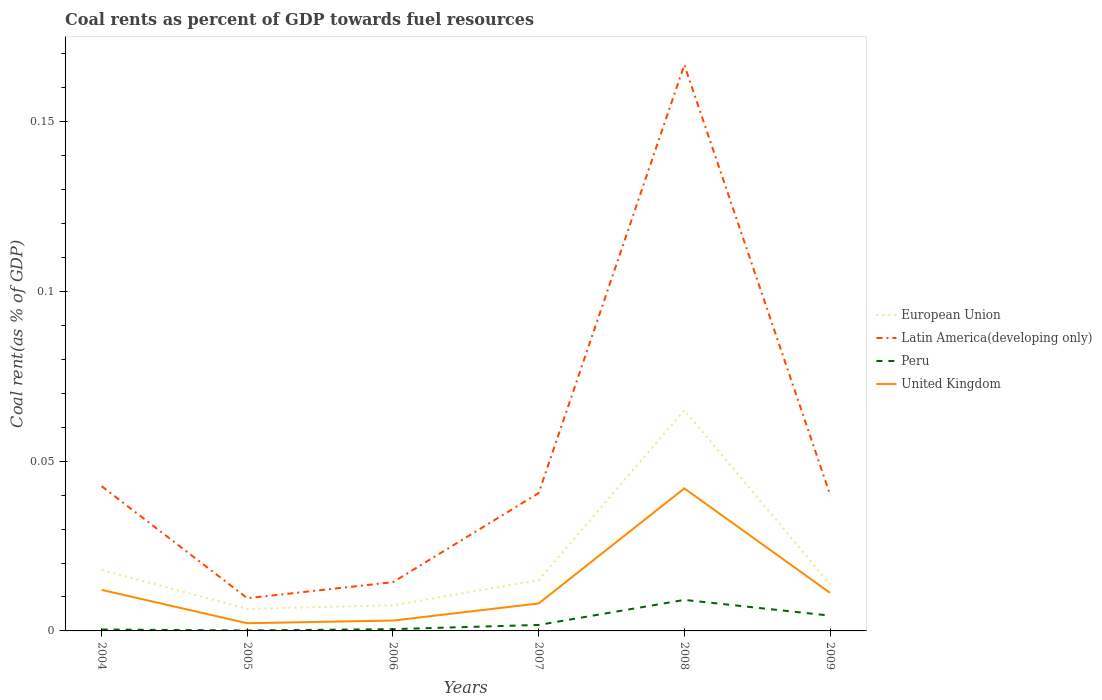Across all years, what is the maximum coal rent in United Kingdom?
Give a very brief answer. 0. What is the total coal rent in United Kingdom in the graph?
Give a very brief answer. -0.03. What is the difference between the highest and the second highest coal rent in European Union?
Your answer should be compact. 0.06. Is the coal rent in European Union strictly greater than the coal rent in Latin America(developing only) over the years?
Offer a terse response. Yes. Are the values on the major ticks of Y-axis written in scientific E-notation?
Give a very brief answer. No. Does the graph contain any zero values?
Offer a terse response. No. Does the graph contain grids?
Offer a very short reply. No. Where does the legend appear in the graph?
Offer a very short reply. Center right. How many legend labels are there?
Offer a terse response. 4. How are the legend labels stacked?
Your response must be concise. Vertical. What is the title of the graph?
Provide a short and direct response. Coal rents as percent of GDP towards fuel resources. What is the label or title of the X-axis?
Offer a very short reply. Years. What is the label or title of the Y-axis?
Offer a very short reply. Coal rent(as % of GDP). What is the Coal rent(as % of GDP) of European Union in 2004?
Ensure brevity in your answer.  0.02. What is the Coal rent(as % of GDP) of Latin America(developing only) in 2004?
Offer a terse response. 0.04. What is the Coal rent(as % of GDP) of Peru in 2004?
Ensure brevity in your answer.  0. What is the Coal rent(as % of GDP) in United Kingdom in 2004?
Make the answer very short. 0.01. What is the Coal rent(as % of GDP) of European Union in 2005?
Offer a very short reply. 0.01. What is the Coal rent(as % of GDP) in Latin America(developing only) in 2005?
Provide a succinct answer. 0.01. What is the Coal rent(as % of GDP) of Peru in 2005?
Offer a terse response. 0. What is the Coal rent(as % of GDP) in United Kingdom in 2005?
Provide a short and direct response. 0. What is the Coal rent(as % of GDP) of European Union in 2006?
Your response must be concise. 0.01. What is the Coal rent(as % of GDP) in Latin America(developing only) in 2006?
Ensure brevity in your answer.  0.01. What is the Coal rent(as % of GDP) in Peru in 2006?
Your answer should be compact. 0. What is the Coal rent(as % of GDP) in United Kingdom in 2006?
Ensure brevity in your answer.  0. What is the Coal rent(as % of GDP) of European Union in 2007?
Your response must be concise. 0.01. What is the Coal rent(as % of GDP) of Latin America(developing only) in 2007?
Ensure brevity in your answer.  0.04. What is the Coal rent(as % of GDP) of Peru in 2007?
Keep it short and to the point. 0. What is the Coal rent(as % of GDP) in United Kingdom in 2007?
Give a very brief answer. 0.01. What is the Coal rent(as % of GDP) in European Union in 2008?
Your answer should be compact. 0.07. What is the Coal rent(as % of GDP) of Latin America(developing only) in 2008?
Offer a terse response. 0.17. What is the Coal rent(as % of GDP) of Peru in 2008?
Offer a terse response. 0.01. What is the Coal rent(as % of GDP) of United Kingdom in 2008?
Offer a terse response. 0.04. What is the Coal rent(as % of GDP) of European Union in 2009?
Provide a succinct answer. 0.01. What is the Coal rent(as % of GDP) in Latin America(developing only) in 2009?
Your response must be concise. 0.04. What is the Coal rent(as % of GDP) of Peru in 2009?
Ensure brevity in your answer.  0. What is the Coal rent(as % of GDP) in United Kingdom in 2009?
Offer a terse response. 0.01. Across all years, what is the maximum Coal rent(as % of GDP) in European Union?
Make the answer very short. 0.07. Across all years, what is the maximum Coal rent(as % of GDP) in Latin America(developing only)?
Ensure brevity in your answer.  0.17. Across all years, what is the maximum Coal rent(as % of GDP) in Peru?
Offer a very short reply. 0.01. Across all years, what is the maximum Coal rent(as % of GDP) in United Kingdom?
Ensure brevity in your answer.  0.04. Across all years, what is the minimum Coal rent(as % of GDP) in European Union?
Offer a terse response. 0.01. Across all years, what is the minimum Coal rent(as % of GDP) in Latin America(developing only)?
Offer a terse response. 0.01. Across all years, what is the minimum Coal rent(as % of GDP) in Peru?
Offer a terse response. 0. Across all years, what is the minimum Coal rent(as % of GDP) of United Kingdom?
Ensure brevity in your answer.  0. What is the total Coal rent(as % of GDP) of European Union in the graph?
Make the answer very short. 0.13. What is the total Coal rent(as % of GDP) of Latin America(developing only) in the graph?
Give a very brief answer. 0.31. What is the total Coal rent(as % of GDP) of Peru in the graph?
Ensure brevity in your answer.  0.02. What is the total Coal rent(as % of GDP) of United Kingdom in the graph?
Your answer should be compact. 0.08. What is the difference between the Coal rent(as % of GDP) in European Union in 2004 and that in 2005?
Ensure brevity in your answer.  0.01. What is the difference between the Coal rent(as % of GDP) of Latin America(developing only) in 2004 and that in 2005?
Offer a very short reply. 0.03. What is the difference between the Coal rent(as % of GDP) of Peru in 2004 and that in 2005?
Ensure brevity in your answer.  0. What is the difference between the Coal rent(as % of GDP) in United Kingdom in 2004 and that in 2005?
Keep it short and to the point. 0.01. What is the difference between the Coal rent(as % of GDP) in European Union in 2004 and that in 2006?
Provide a succinct answer. 0.01. What is the difference between the Coal rent(as % of GDP) in Latin America(developing only) in 2004 and that in 2006?
Provide a succinct answer. 0.03. What is the difference between the Coal rent(as % of GDP) of Peru in 2004 and that in 2006?
Make the answer very short. -0. What is the difference between the Coal rent(as % of GDP) in United Kingdom in 2004 and that in 2006?
Keep it short and to the point. 0.01. What is the difference between the Coal rent(as % of GDP) of European Union in 2004 and that in 2007?
Offer a terse response. 0. What is the difference between the Coal rent(as % of GDP) in Latin America(developing only) in 2004 and that in 2007?
Keep it short and to the point. 0. What is the difference between the Coal rent(as % of GDP) of Peru in 2004 and that in 2007?
Provide a short and direct response. -0. What is the difference between the Coal rent(as % of GDP) of United Kingdom in 2004 and that in 2007?
Your answer should be very brief. 0. What is the difference between the Coal rent(as % of GDP) in European Union in 2004 and that in 2008?
Provide a succinct answer. -0.05. What is the difference between the Coal rent(as % of GDP) in Latin America(developing only) in 2004 and that in 2008?
Provide a succinct answer. -0.12. What is the difference between the Coal rent(as % of GDP) in Peru in 2004 and that in 2008?
Offer a very short reply. -0.01. What is the difference between the Coal rent(as % of GDP) in United Kingdom in 2004 and that in 2008?
Your answer should be very brief. -0.03. What is the difference between the Coal rent(as % of GDP) of European Union in 2004 and that in 2009?
Provide a short and direct response. 0. What is the difference between the Coal rent(as % of GDP) of Latin America(developing only) in 2004 and that in 2009?
Provide a succinct answer. 0. What is the difference between the Coal rent(as % of GDP) of Peru in 2004 and that in 2009?
Provide a succinct answer. -0. What is the difference between the Coal rent(as % of GDP) in United Kingdom in 2004 and that in 2009?
Your answer should be very brief. 0. What is the difference between the Coal rent(as % of GDP) in European Union in 2005 and that in 2006?
Offer a terse response. -0. What is the difference between the Coal rent(as % of GDP) in Latin America(developing only) in 2005 and that in 2006?
Keep it short and to the point. -0. What is the difference between the Coal rent(as % of GDP) of Peru in 2005 and that in 2006?
Give a very brief answer. -0. What is the difference between the Coal rent(as % of GDP) of United Kingdom in 2005 and that in 2006?
Give a very brief answer. -0. What is the difference between the Coal rent(as % of GDP) in European Union in 2005 and that in 2007?
Provide a succinct answer. -0.01. What is the difference between the Coal rent(as % of GDP) in Latin America(developing only) in 2005 and that in 2007?
Make the answer very short. -0.03. What is the difference between the Coal rent(as % of GDP) in Peru in 2005 and that in 2007?
Give a very brief answer. -0. What is the difference between the Coal rent(as % of GDP) in United Kingdom in 2005 and that in 2007?
Provide a short and direct response. -0.01. What is the difference between the Coal rent(as % of GDP) in European Union in 2005 and that in 2008?
Your response must be concise. -0.06. What is the difference between the Coal rent(as % of GDP) in Latin America(developing only) in 2005 and that in 2008?
Provide a succinct answer. -0.16. What is the difference between the Coal rent(as % of GDP) in Peru in 2005 and that in 2008?
Offer a very short reply. -0.01. What is the difference between the Coal rent(as % of GDP) in United Kingdom in 2005 and that in 2008?
Your response must be concise. -0.04. What is the difference between the Coal rent(as % of GDP) in European Union in 2005 and that in 2009?
Make the answer very short. -0.01. What is the difference between the Coal rent(as % of GDP) in Latin America(developing only) in 2005 and that in 2009?
Your response must be concise. -0.03. What is the difference between the Coal rent(as % of GDP) in Peru in 2005 and that in 2009?
Provide a succinct answer. -0. What is the difference between the Coal rent(as % of GDP) in United Kingdom in 2005 and that in 2009?
Give a very brief answer. -0.01. What is the difference between the Coal rent(as % of GDP) of European Union in 2006 and that in 2007?
Your answer should be very brief. -0.01. What is the difference between the Coal rent(as % of GDP) of Latin America(developing only) in 2006 and that in 2007?
Provide a short and direct response. -0.03. What is the difference between the Coal rent(as % of GDP) in Peru in 2006 and that in 2007?
Offer a terse response. -0. What is the difference between the Coal rent(as % of GDP) of United Kingdom in 2006 and that in 2007?
Your response must be concise. -0.01. What is the difference between the Coal rent(as % of GDP) of European Union in 2006 and that in 2008?
Ensure brevity in your answer.  -0.06. What is the difference between the Coal rent(as % of GDP) in Latin America(developing only) in 2006 and that in 2008?
Offer a terse response. -0.15. What is the difference between the Coal rent(as % of GDP) of Peru in 2006 and that in 2008?
Your answer should be compact. -0.01. What is the difference between the Coal rent(as % of GDP) in United Kingdom in 2006 and that in 2008?
Your answer should be compact. -0.04. What is the difference between the Coal rent(as % of GDP) of European Union in 2006 and that in 2009?
Your answer should be very brief. -0.01. What is the difference between the Coal rent(as % of GDP) in Latin America(developing only) in 2006 and that in 2009?
Offer a terse response. -0.03. What is the difference between the Coal rent(as % of GDP) in Peru in 2006 and that in 2009?
Provide a succinct answer. -0. What is the difference between the Coal rent(as % of GDP) in United Kingdom in 2006 and that in 2009?
Keep it short and to the point. -0.01. What is the difference between the Coal rent(as % of GDP) of European Union in 2007 and that in 2008?
Ensure brevity in your answer.  -0.05. What is the difference between the Coal rent(as % of GDP) in Latin America(developing only) in 2007 and that in 2008?
Keep it short and to the point. -0.13. What is the difference between the Coal rent(as % of GDP) in Peru in 2007 and that in 2008?
Offer a terse response. -0.01. What is the difference between the Coal rent(as % of GDP) of United Kingdom in 2007 and that in 2008?
Provide a short and direct response. -0.03. What is the difference between the Coal rent(as % of GDP) of European Union in 2007 and that in 2009?
Provide a succinct answer. 0. What is the difference between the Coal rent(as % of GDP) in Latin America(developing only) in 2007 and that in 2009?
Your answer should be compact. 0. What is the difference between the Coal rent(as % of GDP) in Peru in 2007 and that in 2009?
Your response must be concise. -0. What is the difference between the Coal rent(as % of GDP) of United Kingdom in 2007 and that in 2009?
Keep it short and to the point. -0. What is the difference between the Coal rent(as % of GDP) of European Union in 2008 and that in 2009?
Make the answer very short. 0.05. What is the difference between the Coal rent(as % of GDP) in Latin America(developing only) in 2008 and that in 2009?
Your response must be concise. 0.13. What is the difference between the Coal rent(as % of GDP) in Peru in 2008 and that in 2009?
Ensure brevity in your answer.  0. What is the difference between the Coal rent(as % of GDP) of United Kingdom in 2008 and that in 2009?
Offer a very short reply. 0.03. What is the difference between the Coal rent(as % of GDP) of European Union in 2004 and the Coal rent(as % of GDP) of Latin America(developing only) in 2005?
Your answer should be very brief. 0.01. What is the difference between the Coal rent(as % of GDP) in European Union in 2004 and the Coal rent(as % of GDP) in Peru in 2005?
Provide a succinct answer. 0.02. What is the difference between the Coal rent(as % of GDP) in European Union in 2004 and the Coal rent(as % of GDP) in United Kingdom in 2005?
Your answer should be very brief. 0.02. What is the difference between the Coal rent(as % of GDP) of Latin America(developing only) in 2004 and the Coal rent(as % of GDP) of Peru in 2005?
Offer a very short reply. 0.04. What is the difference between the Coal rent(as % of GDP) of Latin America(developing only) in 2004 and the Coal rent(as % of GDP) of United Kingdom in 2005?
Make the answer very short. 0.04. What is the difference between the Coal rent(as % of GDP) of Peru in 2004 and the Coal rent(as % of GDP) of United Kingdom in 2005?
Keep it short and to the point. -0. What is the difference between the Coal rent(as % of GDP) of European Union in 2004 and the Coal rent(as % of GDP) of Latin America(developing only) in 2006?
Offer a very short reply. 0. What is the difference between the Coal rent(as % of GDP) in European Union in 2004 and the Coal rent(as % of GDP) in Peru in 2006?
Your answer should be very brief. 0.02. What is the difference between the Coal rent(as % of GDP) in European Union in 2004 and the Coal rent(as % of GDP) in United Kingdom in 2006?
Make the answer very short. 0.01. What is the difference between the Coal rent(as % of GDP) in Latin America(developing only) in 2004 and the Coal rent(as % of GDP) in Peru in 2006?
Your answer should be very brief. 0.04. What is the difference between the Coal rent(as % of GDP) of Latin America(developing only) in 2004 and the Coal rent(as % of GDP) of United Kingdom in 2006?
Ensure brevity in your answer.  0.04. What is the difference between the Coal rent(as % of GDP) in Peru in 2004 and the Coal rent(as % of GDP) in United Kingdom in 2006?
Provide a short and direct response. -0. What is the difference between the Coal rent(as % of GDP) in European Union in 2004 and the Coal rent(as % of GDP) in Latin America(developing only) in 2007?
Offer a very short reply. -0.02. What is the difference between the Coal rent(as % of GDP) in European Union in 2004 and the Coal rent(as % of GDP) in Peru in 2007?
Your response must be concise. 0.02. What is the difference between the Coal rent(as % of GDP) of European Union in 2004 and the Coal rent(as % of GDP) of United Kingdom in 2007?
Offer a very short reply. 0.01. What is the difference between the Coal rent(as % of GDP) in Latin America(developing only) in 2004 and the Coal rent(as % of GDP) in Peru in 2007?
Your answer should be very brief. 0.04. What is the difference between the Coal rent(as % of GDP) in Latin America(developing only) in 2004 and the Coal rent(as % of GDP) in United Kingdom in 2007?
Offer a very short reply. 0.03. What is the difference between the Coal rent(as % of GDP) of Peru in 2004 and the Coal rent(as % of GDP) of United Kingdom in 2007?
Your answer should be very brief. -0.01. What is the difference between the Coal rent(as % of GDP) in European Union in 2004 and the Coal rent(as % of GDP) in Latin America(developing only) in 2008?
Keep it short and to the point. -0.15. What is the difference between the Coal rent(as % of GDP) in European Union in 2004 and the Coal rent(as % of GDP) in Peru in 2008?
Provide a short and direct response. 0.01. What is the difference between the Coal rent(as % of GDP) in European Union in 2004 and the Coal rent(as % of GDP) in United Kingdom in 2008?
Offer a terse response. -0.02. What is the difference between the Coal rent(as % of GDP) in Latin America(developing only) in 2004 and the Coal rent(as % of GDP) in Peru in 2008?
Provide a short and direct response. 0.03. What is the difference between the Coal rent(as % of GDP) in Latin America(developing only) in 2004 and the Coal rent(as % of GDP) in United Kingdom in 2008?
Provide a short and direct response. 0. What is the difference between the Coal rent(as % of GDP) of Peru in 2004 and the Coal rent(as % of GDP) of United Kingdom in 2008?
Provide a short and direct response. -0.04. What is the difference between the Coal rent(as % of GDP) of European Union in 2004 and the Coal rent(as % of GDP) of Latin America(developing only) in 2009?
Provide a succinct answer. -0.02. What is the difference between the Coal rent(as % of GDP) of European Union in 2004 and the Coal rent(as % of GDP) of Peru in 2009?
Keep it short and to the point. 0.01. What is the difference between the Coal rent(as % of GDP) in European Union in 2004 and the Coal rent(as % of GDP) in United Kingdom in 2009?
Give a very brief answer. 0.01. What is the difference between the Coal rent(as % of GDP) of Latin America(developing only) in 2004 and the Coal rent(as % of GDP) of Peru in 2009?
Ensure brevity in your answer.  0.04. What is the difference between the Coal rent(as % of GDP) of Latin America(developing only) in 2004 and the Coal rent(as % of GDP) of United Kingdom in 2009?
Ensure brevity in your answer.  0.03. What is the difference between the Coal rent(as % of GDP) of Peru in 2004 and the Coal rent(as % of GDP) of United Kingdom in 2009?
Give a very brief answer. -0.01. What is the difference between the Coal rent(as % of GDP) of European Union in 2005 and the Coal rent(as % of GDP) of Latin America(developing only) in 2006?
Make the answer very short. -0.01. What is the difference between the Coal rent(as % of GDP) of European Union in 2005 and the Coal rent(as % of GDP) of Peru in 2006?
Ensure brevity in your answer.  0.01. What is the difference between the Coal rent(as % of GDP) of European Union in 2005 and the Coal rent(as % of GDP) of United Kingdom in 2006?
Offer a very short reply. 0. What is the difference between the Coal rent(as % of GDP) of Latin America(developing only) in 2005 and the Coal rent(as % of GDP) of Peru in 2006?
Give a very brief answer. 0.01. What is the difference between the Coal rent(as % of GDP) of Latin America(developing only) in 2005 and the Coal rent(as % of GDP) of United Kingdom in 2006?
Your answer should be compact. 0.01. What is the difference between the Coal rent(as % of GDP) of Peru in 2005 and the Coal rent(as % of GDP) of United Kingdom in 2006?
Keep it short and to the point. -0. What is the difference between the Coal rent(as % of GDP) in European Union in 2005 and the Coal rent(as % of GDP) in Latin America(developing only) in 2007?
Offer a terse response. -0.03. What is the difference between the Coal rent(as % of GDP) in European Union in 2005 and the Coal rent(as % of GDP) in Peru in 2007?
Your response must be concise. 0. What is the difference between the Coal rent(as % of GDP) in European Union in 2005 and the Coal rent(as % of GDP) in United Kingdom in 2007?
Your response must be concise. -0. What is the difference between the Coal rent(as % of GDP) of Latin America(developing only) in 2005 and the Coal rent(as % of GDP) of Peru in 2007?
Provide a succinct answer. 0.01. What is the difference between the Coal rent(as % of GDP) in Latin America(developing only) in 2005 and the Coal rent(as % of GDP) in United Kingdom in 2007?
Offer a very short reply. 0. What is the difference between the Coal rent(as % of GDP) of Peru in 2005 and the Coal rent(as % of GDP) of United Kingdom in 2007?
Provide a succinct answer. -0.01. What is the difference between the Coal rent(as % of GDP) of European Union in 2005 and the Coal rent(as % of GDP) of Latin America(developing only) in 2008?
Your answer should be compact. -0.16. What is the difference between the Coal rent(as % of GDP) in European Union in 2005 and the Coal rent(as % of GDP) in Peru in 2008?
Offer a very short reply. -0. What is the difference between the Coal rent(as % of GDP) of European Union in 2005 and the Coal rent(as % of GDP) of United Kingdom in 2008?
Your answer should be compact. -0.04. What is the difference between the Coal rent(as % of GDP) in Latin America(developing only) in 2005 and the Coal rent(as % of GDP) in United Kingdom in 2008?
Offer a terse response. -0.03. What is the difference between the Coal rent(as % of GDP) of Peru in 2005 and the Coal rent(as % of GDP) of United Kingdom in 2008?
Keep it short and to the point. -0.04. What is the difference between the Coal rent(as % of GDP) in European Union in 2005 and the Coal rent(as % of GDP) in Latin America(developing only) in 2009?
Offer a very short reply. -0.03. What is the difference between the Coal rent(as % of GDP) of European Union in 2005 and the Coal rent(as % of GDP) of Peru in 2009?
Give a very brief answer. 0. What is the difference between the Coal rent(as % of GDP) of European Union in 2005 and the Coal rent(as % of GDP) of United Kingdom in 2009?
Ensure brevity in your answer.  -0. What is the difference between the Coal rent(as % of GDP) of Latin America(developing only) in 2005 and the Coal rent(as % of GDP) of Peru in 2009?
Keep it short and to the point. 0.01. What is the difference between the Coal rent(as % of GDP) in Latin America(developing only) in 2005 and the Coal rent(as % of GDP) in United Kingdom in 2009?
Your answer should be compact. -0. What is the difference between the Coal rent(as % of GDP) in Peru in 2005 and the Coal rent(as % of GDP) in United Kingdom in 2009?
Keep it short and to the point. -0.01. What is the difference between the Coal rent(as % of GDP) in European Union in 2006 and the Coal rent(as % of GDP) in Latin America(developing only) in 2007?
Make the answer very short. -0.03. What is the difference between the Coal rent(as % of GDP) in European Union in 2006 and the Coal rent(as % of GDP) in Peru in 2007?
Make the answer very short. 0.01. What is the difference between the Coal rent(as % of GDP) in European Union in 2006 and the Coal rent(as % of GDP) in United Kingdom in 2007?
Your answer should be compact. -0. What is the difference between the Coal rent(as % of GDP) in Latin America(developing only) in 2006 and the Coal rent(as % of GDP) in Peru in 2007?
Offer a terse response. 0.01. What is the difference between the Coal rent(as % of GDP) of Latin America(developing only) in 2006 and the Coal rent(as % of GDP) of United Kingdom in 2007?
Keep it short and to the point. 0.01. What is the difference between the Coal rent(as % of GDP) of Peru in 2006 and the Coal rent(as % of GDP) of United Kingdom in 2007?
Provide a short and direct response. -0.01. What is the difference between the Coal rent(as % of GDP) of European Union in 2006 and the Coal rent(as % of GDP) of Latin America(developing only) in 2008?
Make the answer very short. -0.16. What is the difference between the Coal rent(as % of GDP) in European Union in 2006 and the Coal rent(as % of GDP) in Peru in 2008?
Keep it short and to the point. -0. What is the difference between the Coal rent(as % of GDP) in European Union in 2006 and the Coal rent(as % of GDP) in United Kingdom in 2008?
Ensure brevity in your answer.  -0.03. What is the difference between the Coal rent(as % of GDP) in Latin America(developing only) in 2006 and the Coal rent(as % of GDP) in Peru in 2008?
Ensure brevity in your answer.  0.01. What is the difference between the Coal rent(as % of GDP) in Latin America(developing only) in 2006 and the Coal rent(as % of GDP) in United Kingdom in 2008?
Keep it short and to the point. -0.03. What is the difference between the Coal rent(as % of GDP) of Peru in 2006 and the Coal rent(as % of GDP) of United Kingdom in 2008?
Offer a very short reply. -0.04. What is the difference between the Coal rent(as % of GDP) of European Union in 2006 and the Coal rent(as % of GDP) of Latin America(developing only) in 2009?
Provide a short and direct response. -0.03. What is the difference between the Coal rent(as % of GDP) of European Union in 2006 and the Coal rent(as % of GDP) of Peru in 2009?
Your answer should be compact. 0. What is the difference between the Coal rent(as % of GDP) of European Union in 2006 and the Coal rent(as % of GDP) of United Kingdom in 2009?
Your response must be concise. -0. What is the difference between the Coal rent(as % of GDP) in Latin America(developing only) in 2006 and the Coal rent(as % of GDP) in Peru in 2009?
Offer a terse response. 0.01. What is the difference between the Coal rent(as % of GDP) of Latin America(developing only) in 2006 and the Coal rent(as % of GDP) of United Kingdom in 2009?
Offer a terse response. 0. What is the difference between the Coal rent(as % of GDP) in Peru in 2006 and the Coal rent(as % of GDP) in United Kingdom in 2009?
Offer a very short reply. -0.01. What is the difference between the Coal rent(as % of GDP) of European Union in 2007 and the Coal rent(as % of GDP) of Latin America(developing only) in 2008?
Offer a terse response. -0.15. What is the difference between the Coal rent(as % of GDP) in European Union in 2007 and the Coal rent(as % of GDP) in Peru in 2008?
Your answer should be compact. 0.01. What is the difference between the Coal rent(as % of GDP) of European Union in 2007 and the Coal rent(as % of GDP) of United Kingdom in 2008?
Offer a very short reply. -0.03. What is the difference between the Coal rent(as % of GDP) in Latin America(developing only) in 2007 and the Coal rent(as % of GDP) in Peru in 2008?
Ensure brevity in your answer.  0.03. What is the difference between the Coal rent(as % of GDP) of Latin America(developing only) in 2007 and the Coal rent(as % of GDP) of United Kingdom in 2008?
Provide a succinct answer. -0. What is the difference between the Coal rent(as % of GDP) of Peru in 2007 and the Coal rent(as % of GDP) of United Kingdom in 2008?
Give a very brief answer. -0.04. What is the difference between the Coal rent(as % of GDP) in European Union in 2007 and the Coal rent(as % of GDP) in Latin America(developing only) in 2009?
Your answer should be compact. -0.03. What is the difference between the Coal rent(as % of GDP) of European Union in 2007 and the Coal rent(as % of GDP) of Peru in 2009?
Give a very brief answer. 0.01. What is the difference between the Coal rent(as % of GDP) of European Union in 2007 and the Coal rent(as % of GDP) of United Kingdom in 2009?
Give a very brief answer. 0. What is the difference between the Coal rent(as % of GDP) in Latin America(developing only) in 2007 and the Coal rent(as % of GDP) in Peru in 2009?
Your answer should be compact. 0.04. What is the difference between the Coal rent(as % of GDP) in Latin America(developing only) in 2007 and the Coal rent(as % of GDP) in United Kingdom in 2009?
Ensure brevity in your answer.  0.03. What is the difference between the Coal rent(as % of GDP) in Peru in 2007 and the Coal rent(as % of GDP) in United Kingdom in 2009?
Offer a very short reply. -0.01. What is the difference between the Coal rent(as % of GDP) of European Union in 2008 and the Coal rent(as % of GDP) of Latin America(developing only) in 2009?
Provide a succinct answer. 0.02. What is the difference between the Coal rent(as % of GDP) of European Union in 2008 and the Coal rent(as % of GDP) of Peru in 2009?
Offer a very short reply. 0.06. What is the difference between the Coal rent(as % of GDP) of European Union in 2008 and the Coal rent(as % of GDP) of United Kingdom in 2009?
Offer a terse response. 0.05. What is the difference between the Coal rent(as % of GDP) of Latin America(developing only) in 2008 and the Coal rent(as % of GDP) of Peru in 2009?
Provide a succinct answer. 0.16. What is the difference between the Coal rent(as % of GDP) in Latin America(developing only) in 2008 and the Coal rent(as % of GDP) in United Kingdom in 2009?
Your answer should be very brief. 0.16. What is the difference between the Coal rent(as % of GDP) in Peru in 2008 and the Coal rent(as % of GDP) in United Kingdom in 2009?
Your response must be concise. -0. What is the average Coal rent(as % of GDP) in European Union per year?
Give a very brief answer. 0.02. What is the average Coal rent(as % of GDP) in Latin America(developing only) per year?
Your answer should be very brief. 0.05. What is the average Coal rent(as % of GDP) in Peru per year?
Make the answer very short. 0. What is the average Coal rent(as % of GDP) in United Kingdom per year?
Keep it short and to the point. 0.01. In the year 2004, what is the difference between the Coal rent(as % of GDP) of European Union and Coal rent(as % of GDP) of Latin America(developing only)?
Offer a very short reply. -0.02. In the year 2004, what is the difference between the Coal rent(as % of GDP) of European Union and Coal rent(as % of GDP) of Peru?
Your answer should be compact. 0.02. In the year 2004, what is the difference between the Coal rent(as % of GDP) in European Union and Coal rent(as % of GDP) in United Kingdom?
Your answer should be very brief. 0.01. In the year 2004, what is the difference between the Coal rent(as % of GDP) of Latin America(developing only) and Coal rent(as % of GDP) of Peru?
Provide a succinct answer. 0.04. In the year 2004, what is the difference between the Coal rent(as % of GDP) of Latin America(developing only) and Coal rent(as % of GDP) of United Kingdom?
Provide a short and direct response. 0.03. In the year 2004, what is the difference between the Coal rent(as % of GDP) of Peru and Coal rent(as % of GDP) of United Kingdom?
Keep it short and to the point. -0.01. In the year 2005, what is the difference between the Coal rent(as % of GDP) of European Union and Coal rent(as % of GDP) of Latin America(developing only)?
Make the answer very short. -0. In the year 2005, what is the difference between the Coal rent(as % of GDP) in European Union and Coal rent(as % of GDP) in Peru?
Offer a very short reply. 0.01. In the year 2005, what is the difference between the Coal rent(as % of GDP) in European Union and Coal rent(as % of GDP) in United Kingdom?
Your answer should be very brief. 0. In the year 2005, what is the difference between the Coal rent(as % of GDP) in Latin America(developing only) and Coal rent(as % of GDP) in Peru?
Offer a terse response. 0.01. In the year 2005, what is the difference between the Coal rent(as % of GDP) in Latin America(developing only) and Coal rent(as % of GDP) in United Kingdom?
Provide a short and direct response. 0.01. In the year 2005, what is the difference between the Coal rent(as % of GDP) in Peru and Coal rent(as % of GDP) in United Kingdom?
Offer a very short reply. -0. In the year 2006, what is the difference between the Coal rent(as % of GDP) of European Union and Coal rent(as % of GDP) of Latin America(developing only)?
Keep it short and to the point. -0.01. In the year 2006, what is the difference between the Coal rent(as % of GDP) in European Union and Coal rent(as % of GDP) in Peru?
Your response must be concise. 0.01. In the year 2006, what is the difference between the Coal rent(as % of GDP) in European Union and Coal rent(as % of GDP) in United Kingdom?
Give a very brief answer. 0. In the year 2006, what is the difference between the Coal rent(as % of GDP) of Latin America(developing only) and Coal rent(as % of GDP) of Peru?
Provide a succinct answer. 0.01. In the year 2006, what is the difference between the Coal rent(as % of GDP) in Latin America(developing only) and Coal rent(as % of GDP) in United Kingdom?
Ensure brevity in your answer.  0.01. In the year 2006, what is the difference between the Coal rent(as % of GDP) of Peru and Coal rent(as % of GDP) of United Kingdom?
Give a very brief answer. -0. In the year 2007, what is the difference between the Coal rent(as % of GDP) in European Union and Coal rent(as % of GDP) in Latin America(developing only)?
Provide a short and direct response. -0.03. In the year 2007, what is the difference between the Coal rent(as % of GDP) in European Union and Coal rent(as % of GDP) in Peru?
Provide a short and direct response. 0.01. In the year 2007, what is the difference between the Coal rent(as % of GDP) of European Union and Coal rent(as % of GDP) of United Kingdom?
Make the answer very short. 0.01. In the year 2007, what is the difference between the Coal rent(as % of GDP) of Latin America(developing only) and Coal rent(as % of GDP) of Peru?
Ensure brevity in your answer.  0.04. In the year 2007, what is the difference between the Coal rent(as % of GDP) in Latin America(developing only) and Coal rent(as % of GDP) in United Kingdom?
Make the answer very short. 0.03. In the year 2007, what is the difference between the Coal rent(as % of GDP) of Peru and Coal rent(as % of GDP) of United Kingdom?
Your response must be concise. -0.01. In the year 2008, what is the difference between the Coal rent(as % of GDP) of European Union and Coal rent(as % of GDP) of Latin America(developing only)?
Your answer should be very brief. -0.1. In the year 2008, what is the difference between the Coal rent(as % of GDP) in European Union and Coal rent(as % of GDP) in Peru?
Offer a terse response. 0.06. In the year 2008, what is the difference between the Coal rent(as % of GDP) of European Union and Coal rent(as % of GDP) of United Kingdom?
Offer a very short reply. 0.02. In the year 2008, what is the difference between the Coal rent(as % of GDP) in Latin America(developing only) and Coal rent(as % of GDP) in Peru?
Give a very brief answer. 0.16. In the year 2008, what is the difference between the Coal rent(as % of GDP) of Latin America(developing only) and Coal rent(as % of GDP) of United Kingdom?
Your answer should be compact. 0.12. In the year 2008, what is the difference between the Coal rent(as % of GDP) of Peru and Coal rent(as % of GDP) of United Kingdom?
Keep it short and to the point. -0.03. In the year 2009, what is the difference between the Coal rent(as % of GDP) of European Union and Coal rent(as % of GDP) of Latin America(developing only)?
Ensure brevity in your answer.  -0.03. In the year 2009, what is the difference between the Coal rent(as % of GDP) in European Union and Coal rent(as % of GDP) in Peru?
Provide a succinct answer. 0.01. In the year 2009, what is the difference between the Coal rent(as % of GDP) of European Union and Coal rent(as % of GDP) of United Kingdom?
Make the answer very short. 0. In the year 2009, what is the difference between the Coal rent(as % of GDP) of Latin America(developing only) and Coal rent(as % of GDP) of Peru?
Your answer should be very brief. 0.04. In the year 2009, what is the difference between the Coal rent(as % of GDP) of Latin America(developing only) and Coal rent(as % of GDP) of United Kingdom?
Give a very brief answer. 0.03. In the year 2009, what is the difference between the Coal rent(as % of GDP) of Peru and Coal rent(as % of GDP) of United Kingdom?
Provide a succinct answer. -0.01. What is the ratio of the Coal rent(as % of GDP) in European Union in 2004 to that in 2005?
Offer a terse response. 2.77. What is the ratio of the Coal rent(as % of GDP) of Latin America(developing only) in 2004 to that in 2005?
Give a very brief answer. 4.42. What is the ratio of the Coal rent(as % of GDP) in Peru in 2004 to that in 2005?
Make the answer very short. 3.1. What is the ratio of the Coal rent(as % of GDP) in United Kingdom in 2004 to that in 2005?
Offer a very short reply. 5.34. What is the ratio of the Coal rent(as % of GDP) in European Union in 2004 to that in 2006?
Provide a succinct answer. 2.38. What is the ratio of the Coal rent(as % of GDP) of Latin America(developing only) in 2004 to that in 2006?
Offer a terse response. 2.97. What is the ratio of the Coal rent(as % of GDP) of Peru in 2004 to that in 2006?
Give a very brief answer. 0.79. What is the ratio of the Coal rent(as % of GDP) in United Kingdom in 2004 to that in 2006?
Keep it short and to the point. 3.96. What is the ratio of the Coal rent(as % of GDP) in European Union in 2004 to that in 2007?
Ensure brevity in your answer.  1.2. What is the ratio of the Coal rent(as % of GDP) of Latin America(developing only) in 2004 to that in 2007?
Your answer should be very brief. 1.05. What is the ratio of the Coal rent(as % of GDP) of Peru in 2004 to that in 2007?
Provide a short and direct response. 0.24. What is the ratio of the Coal rent(as % of GDP) of United Kingdom in 2004 to that in 2007?
Your answer should be compact. 1.49. What is the ratio of the Coal rent(as % of GDP) of European Union in 2004 to that in 2008?
Your answer should be compact. 0.28. What is the ratio of the Coal rent(as % of GDP) in Latin America(developing only) in 2004 to that in 2008?
Provide a short and direct response. 0.26. What is the ratio of the Coal rent(as % of GDP) in Peru in 2004 to that in 2008?
Ensure brevity in your answer.  0.05. What is the ratio of the Coal rent(as % of GDP) in United Kingdom in 2004 to that in 2008?
Keep it short and to the point. 0.29. What is the ratio of the Coal rent(as % of GDP) in European Union in 2004 to that in 2009?
Offer a very short reply. 1.31. What is the ratio of the Coal rent(as % of GDP) of Latin America(developing only) in 2004 to that in 2009?
Provide a short and direct response. 1.06. What is the ratio of the Coal rent(as % of GDP) in Peru in 2004 to that in 2009?
Keep it short and to the point. 0.09. What is the ratio of the Coal rent(as % of GDP) of United Kingdom in 2004 to that in 2009?
Ensure brevity in your answer.  1.08. What is the ratio of the Coal rent(as % of GDP) in European Union in 2005 to that in 2006?
Provide a short and direct response. 0.86. What is the ratio of the Coal rent(as % of GDP) in Latin America(developing only) in 2005 to that in 2006?
Give a very brief answer. 0.67. What is the ratio of the Coal rent(as % of GDP) of Peru in 2005 to that in 2006?
Ensure brevity in your answer.  0.26. What is the ratio of the Coal rent(as % of GDP) of United Kingdom in 2005 to that in 2006?
Give a very brief answer. 0.74. What is the ratio of the Coal rent(as % of GDP) in European Union in 2005 to that in 2007?
Make the answer very short. 0.43. What is the ratio of the Coal rent(as % of GDP) of Latin America(developing only) in 2005 to that in 2007?
Provide a short and direct response. 0.24. What is the ratio of the Coal rent(as % of GDP) of Peru in 2005 to that in 2007?
Provide a short and direct response. 0.08. What is the ratio of the Coal rent(as % of GDP) in United Kingdom in 2005 to that in 2007?
Make the answer very short. 0.28. What is the ratio of the Coal rent(as % of GDP) in European Union in 2005 to that in 2008?
Ensure brevity in your answer.  0.1. What is the ratio of the Coal rent(as % of GDP) in Latin America(developing only) in 2005 to that in 2008?
Make the answer very short. 0.06. What is the ratio of the Coal rent(as % of GDP) in Peru in 2005 to that in 2008?
Keep it short and to the point. 0.01. What is the ratio of the Coal rent(as % of GDP) of United Kingdom in 2005 to that in 2008?
Provide a succinct answer. 0.05. What is the ratio of the Coal rent(as % of GDP) of European Union in 2005 to that in 2009?
Your answer should be very brief. 0.47. What is the ratio of the Coal rent(as % of GDP) of Latin America(developing only) in 2005 to that in 2009?
Give a very brief answer. 0.24. What is the ratio of the Coal rent(as % of GDP) of Peru in 2005 to that in 2009?
Make the answer very short. 0.03. What is the ratio of the Coal rent(as % of GDP) in United Kingdom in 2005 to that in 2009?
Your answer should be very brief. 0.2. What is the ratio of the Coal rent(as % of GDP) in European Union in 2006 to that in 2007?
Give a very brief answer. 0.51. What is the ratio of the Coal rent(as % of GDP) of Latin America(developing only) in 2006 to that in 2007?
Keep it short and to the point. 0.35. What is the ratio of the Coal rent(as % of GDP) in Peru in 2006 to that in 2007?
Keep it short and to the point. 0.3. What is the ratio of the Coal rent(as % of GDP) of United Kingdom in 2006 to that in 2007?
Offer a very short reply. 0.38. What is the ratio of the Coal rent(as % of GDP) of European Union in 2006 to that in 2008?
Make the answer very short. 0.12. What is the ratio of the Coal rent(as % of GDP) in Latin America(developing only) in 2006 to that in 2008?
Your response must be concise. 0.09. What is the ratio of the Coal rent(as % of GDP) of Peru in 2006 to that in 2008?
Your response must be concise. 0.06. What is the ratio of the Coal rent(as % of GDP) of United Kingdom in 2006 to that in 2008?
Keep it short and to the point. 0.07. What is the ratio of the Coal rent(as % of GDP) of European Union in 2006 to that in 2009?
Your response must be concise. 0.55. What is the ratio of the Coal rent(as % of GDP) in Latin America(developing only) in 2006 to that in 2009?
Offer a very short reply. 0.36. What is the ratio of the Coal rent(as % of GDP) of Peru in 2006 to that in 2009?
Give a very brief answer. 0.12. What is the ratio of the Coal rent(as % of GDP) of United Kingdom in 2006 to that in 2009?
Ensure brevity in your answer.  0.27. What is the ratio of the Coal rent(as % of GDP) in European Union in 2007 to that in 2008?
Make the answer very short. 0.23. What is the ratio of the Coal rent(as % of GDP) in Latin America(developing only) in 2007 to that in 2008?
Provide a succinct answer. 0.24. What is the ratio of the Coal rent(as % of GDP) of Peru in 2007 to that in 2008?
Your answer should be compact. 0.19. What is the ratio of the Coal rent(as % of GDP) of United Kingdom in 2007 to that in 2008?
Offer a terse response. 0.19. What is the ratio of the Coal rent(as % of GDP) in European Union in 2007 to that in 2009?
Provide a succinct answer. 1.09. What is the ratio of the Coal rent(as % of GDP) of Peru in 2007 to that in 2009?
Offer a terse response. 0.39. What is the ratio of the Coal rent(as % of GDP) of United Kingdom in 2007 to that in 2009?
Give a very brief answer. 0.72. What is the ratio of the Coal rent(as % of GDP) of European Union in 2008 to that in 2009?
Offer a very short reply. 4.73. What is the ratio of the Coal rent(as % of GDP) in Latin America(developing only) in 2008 to that in 2009?
Your answer should be very brief. 4.15. What is the ratio of the Coal rent(as % of GDP) in Peru in 2008 to that in 2009?
Ensure brevity in your answer.  2.03. What is the ratio of the Coal rent(as % of GDP) of United Kingdom in 2008 to that in 2009?
Offer a terse response. 3.74. What is the difference between the highest and the second highest Coal rent(as % of GDP) of European Union?
Provide a succinct answer. 0.05. What is the difference between the highest and the second highest Coal rent(as % of GDP) of Latin America(developing only)?
Make the answer very short. 0.12. What is the difference between the highest and the second highest Coal rent(as % of GDP) of Peru?
Your answer should be compact. 0. What is the difference between the highest and the second highest Coal rent(as % of GDP) in United Kingdom?
Provide a short and direct response. 0.03. What is the difference between the highest and the lowest Coal rent(as % of GDP) in European Union?
Provide a short and direct response. 0.06. What is the difference between the highest and the lowest Coal rent(as % of GDP) in Latin America(developing only)?
Your response must be concise. 0.16. What is the difference between the highest and the lowest Coal rent(as % of GDP) in Peru?
Your answer should be compact. 0.01. What is the difference between the highest and the lowest Coal rent(as % of GDP) of United Kingdom?
Your response must be concise. 0.04. 